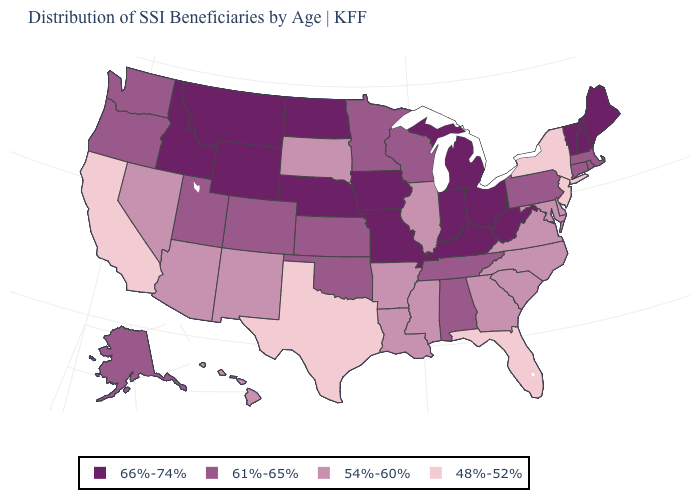What is the lowest value in the USA?
Keep it brief. 48%-52%. How many symbols are there in the legend?
Write a very short answer. 4. What is the value of Connecticut?
Give a very brief answer. 61%-65%. Name the states that have a value in the range 66%-74%?
Concise answer only. Idaho, Indiana, Iowa, Kentucky, Maine, Michigan, Missouri, Montana, Nebraska, New Hampshire, North Dakota, Ohio, Vermont, West Virginia, Wyoming. How many symbols are there in the legend?
Write a very short answer. 4. Which states hav the highest value in the West?
Quick response, please. Idaho, Montana, Wyoming. Which states have the lowest value in the USA?
Keep it brief. California, Florida, New Jersey, New York, Texas. Does Maine have a higher value than New Hampshire?
Give a very brief answer. No. Among the states that border California , does Oregon have the highest value?
Short answer required. Yes. What is the lowest value in states that border South Carolina?
Concise answer only. 54%-60%. Name the states that have a value in the range 48%-52%?
Keep it brief. California, Florida, New Jersey, New York, Texas. What is the highest value in the USA?
Short answer required. 66%-74%. What is the lowest value in states that border Arizona?
Quick response, please. 48%-52%. 